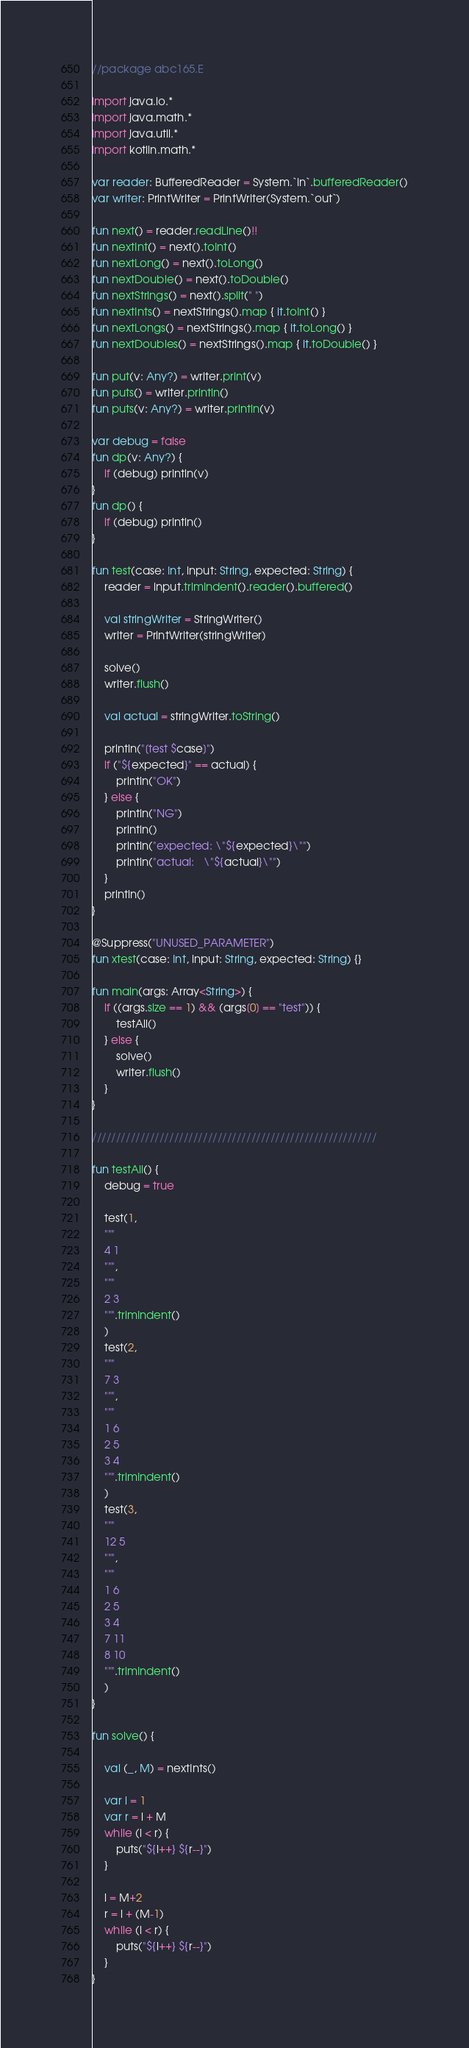Convert code to text. <code><loc_0><loc_0><loc_500><loc_500><_Kotlin_>//package abc165.E

import java.io.*
import java.math.*
import java.util.*
import kotlin.math.*

var reader: BufferedReader = System.`in`.bufferedReader()
var writer: PrintWriter = PrintWriter(System.`out`)

fun next() = reader.readLine()!!
fun nextInt() = next().toInt()
fun nextLong() = next().toLong()
fun nextDouble() = next().toDouble()
fun nextStrings() = next().split(" ")
fun nextInts() = nextStrings().map { it.toInt() }
fun nextLongs() = nextStrings().map { it.toLong() }
fun nextDoubles() = nextStrings().map { it.toDouble() }

fun put(v: Any?) = writer.print(v)
fun puts() = writer.println()
fun puts(v: Any?) = writer.println(v)

var debug = false
fun dp(v: Any?) {
    if (debug) println(v)
}
fun dp() {
    if (debug) println()
}

fun test(case: Int, input: String, expected: String) {
    reader = input.trimIndent().reader().buffered()

    val stringWriter = StringWriter()
    writer = PrintWriter(stringWriter)

    solve()
    writer.flush()

    val actual = stringWriter.toString()

    println("[test $case]")
    if ("${expected}" == actual) {
        println("OK")
    } else {
        println("NG")
        println()
        println("expected: \"${expected}\"")
        println("actual:   \"${actual}\"")
    }
    println()
}

@Suppress("UNUSED_PARAMETER")
fun xtest(case: Int, input: String, expected: String) {}

fun main(args: Array<String>) {
    if ((args.size == 1) && (args[0] == "test")) {
        testAll()
    } else {
        solve()
        writer.flush()
    }
}

///////////////////////////////////////////////////////////

fun testAll() {
    debug = true

    test(1,
    """
    4 1
    """,
    """
    2 3
    """.trimIndent()
    )
    test(2,
    """
    7 3
    """,
    """
    1 6
    2 5
    3 4
    """.trimIndent()
    )
    test(3,
    """
    12 5
    """,
    """
    1 6
    2 5
    3 4
    7 11
    8 10
    """.trimIndent()
    )
}

fun solve() {

    val (_, M) = nextInts()

    var l = 1
    var r = l + M
    while (l < r) {
        puts("${l++} ${r--}")
    }

    l = M+2
    r = l + (M-1)
    while (l < r) {
        puts("${l++} ${r--}")
    }
}
</code> 